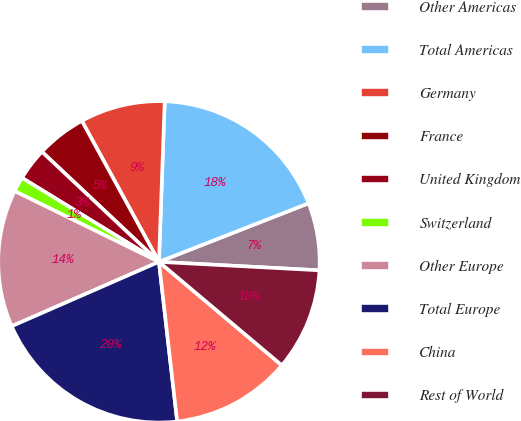Convert chart. <chart><loc_0><loc_0><loc_500><loc_500><pie_chart><fcel>Other Americas<fcel>Total Americas<fcel>Germany<fcel>France<fcel>United Kingdom<fcel>Switzerland<fcel>Other Europe<fcel>Total Europe<fcel>China<fcel>Rest of World<nl><fcel>6.78%<fcel>18.5%<fcel>8.54%<fcel>5.02%<fcel>3.26%<fcel>1.5%<fcel>13.82%<fcel>20.26%<fcel>12.06%<fcel>10.3%<nl></chart> 